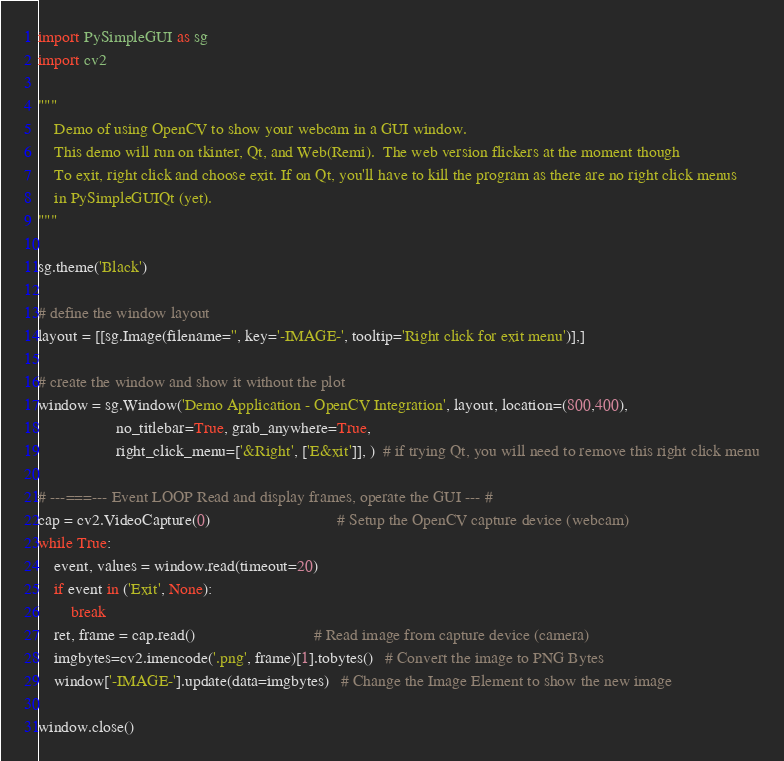Convert code to text. <code><loc_0><loc_0><loc_500><loc_500><_Python_>import PySimpleGUI as sg
import cv2

"""
    Demo of using OpenCV to show your webcam in a GUI window.
    This demo will run on tkinter, Qt, and Web(Remi).  The web version flickers at the moment though
    To exit, right click and choose exit. If on Qt, you'll have to kill the program as there are no right click menus
    in PySimpleGUIQt (yet).
"""

sg.theme('Black')

# define the window layout
layout = [[sg.Image(filename='', key='-IMAGE-', tooltip='Right click for exit menu')],]

# create the window and show it without the plot
window = sg.Window('Demo Application - OpenCV Integration', layout, location=(800,400),
                   no_titlebar=True, grab_anywhere=True,
                   right_click_menu=['&Right', ['E&xit']], )  # if trying Qt, you will need to remove this right click menu

# ---===--- Event LOOP Read and display frames, operate the GUI --- #
cap = cv2.VideoCapture(0)                               # Setup the OpenCV capture device (webcam)
while True:
    event, values = window.read(timeout=20)
    if event in ('Exit', None):
        break
    ret, frame = cap.read()                             # Read image from capture device (camera)
    imgbytes=cv2.imencode('.png', frame)[1].tobytes()   # Convert the image to PNG Bytes
    window['-IMAGE-'].update(data=imgbytes)   # Change the Image Element to show the new image

window.close()
</code> 